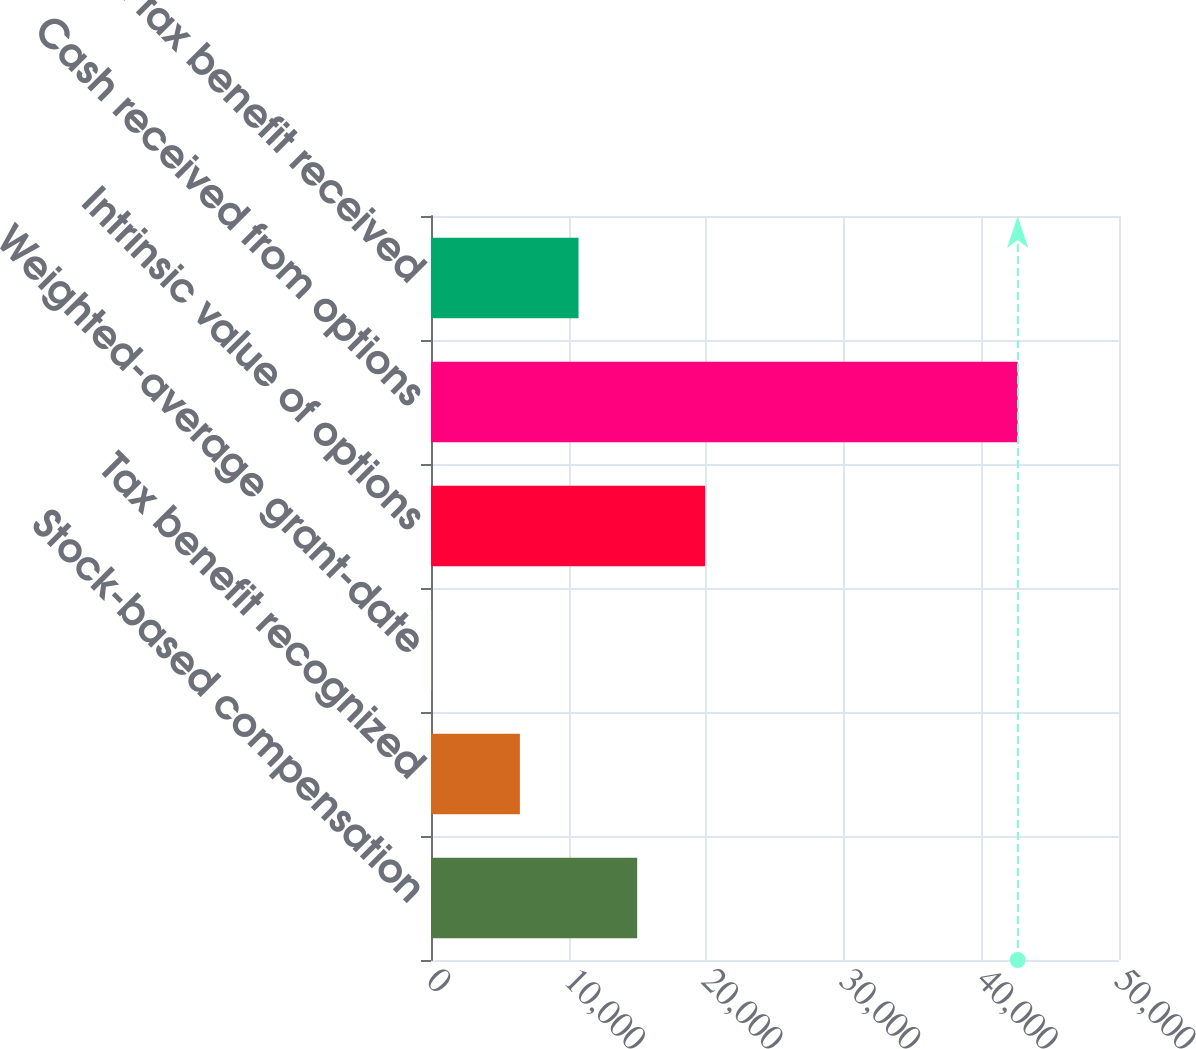<chart> <loc_0><loc_0><loc_500><loc_500><bar_chart><fcel>Stock-based compensation<fcel>Tax benefit recognized<fcel>Weighted-average grant-date<fcel>Intrinsic value of options<fcel>Cash received from options<fcel>Actual tax benefit received<nl><fcel>14984.5<fcel>6460<fcel>12.58<fcel>19924<fcel>42635<fcel>10722.2<nl></chart> 